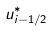<formula> <loc_0><loc_0><loc_500><loc_500>u _ { i - 1 / 2 } ^ { * }</formula> 